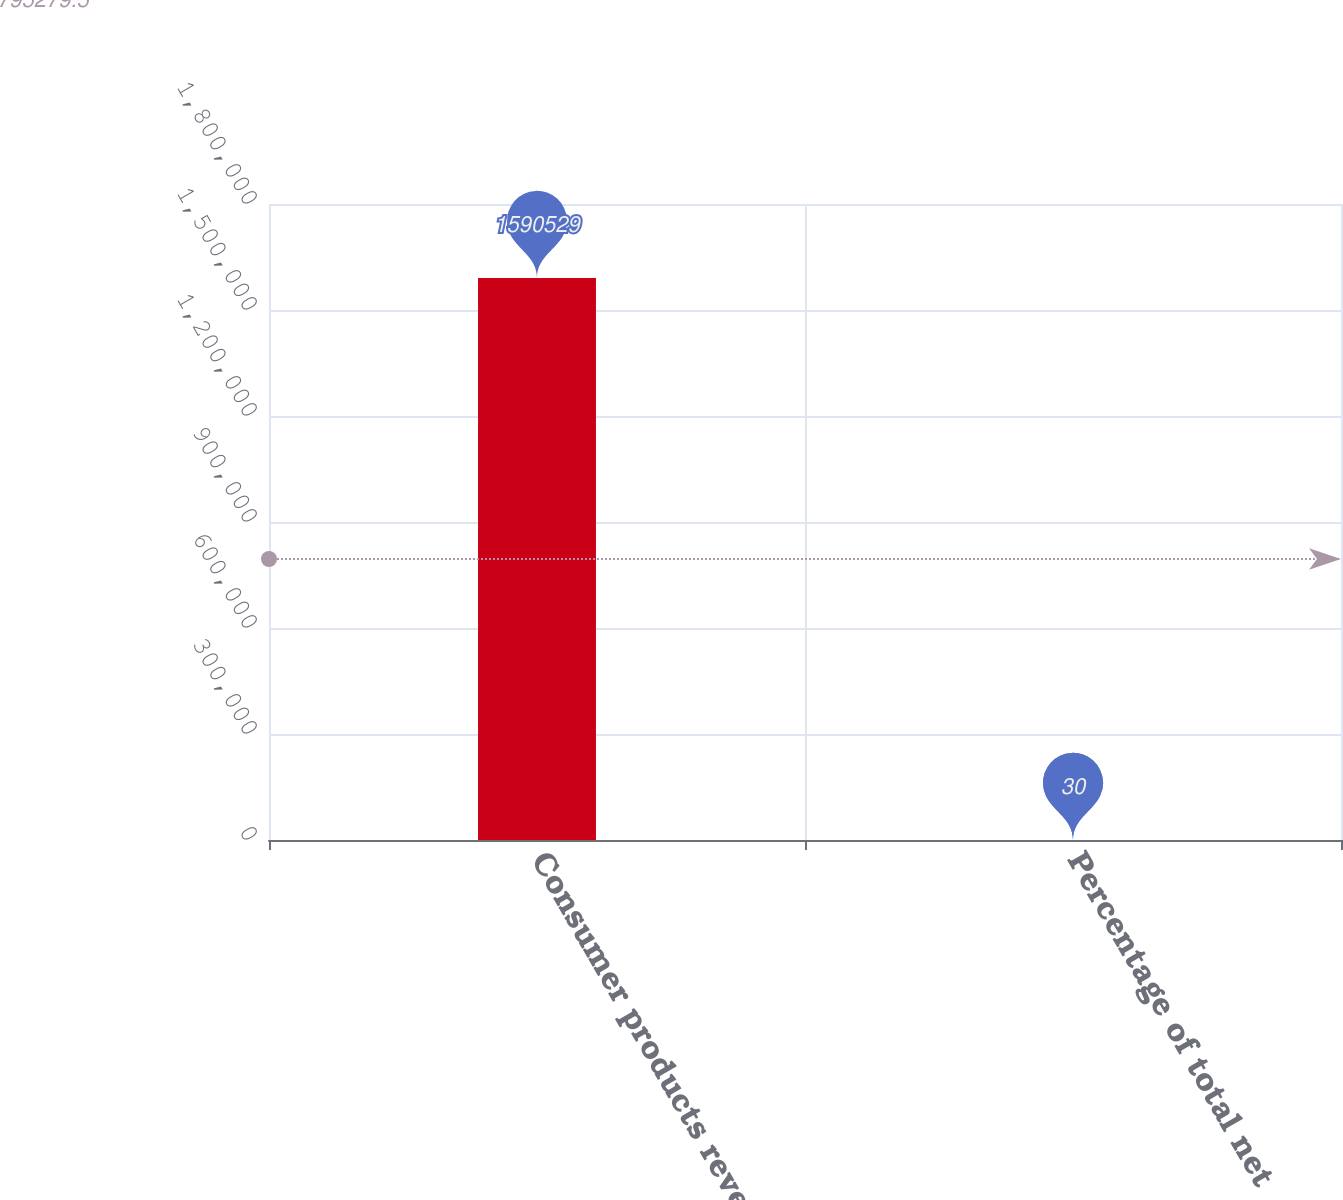<chart> <loc_0><loc_0><loc_500><loc_500><bar_chart><fcel>Consumer products revenues<fcel>Percentage of total net<nl><fcel>1.59053e+06<fcel>30<nl></chart> 